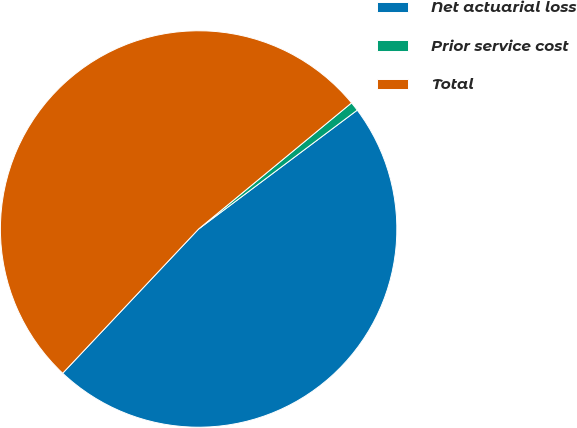<chart> <loc_0><loc_0><loc_500><loc_500><pie_chart><fcel>Net actuarial loss<fcel>Prior service cost<fcel>Total<nl><fcel>47.26%<fcel>0.74%<fcel>51.99%<nl></chart> 